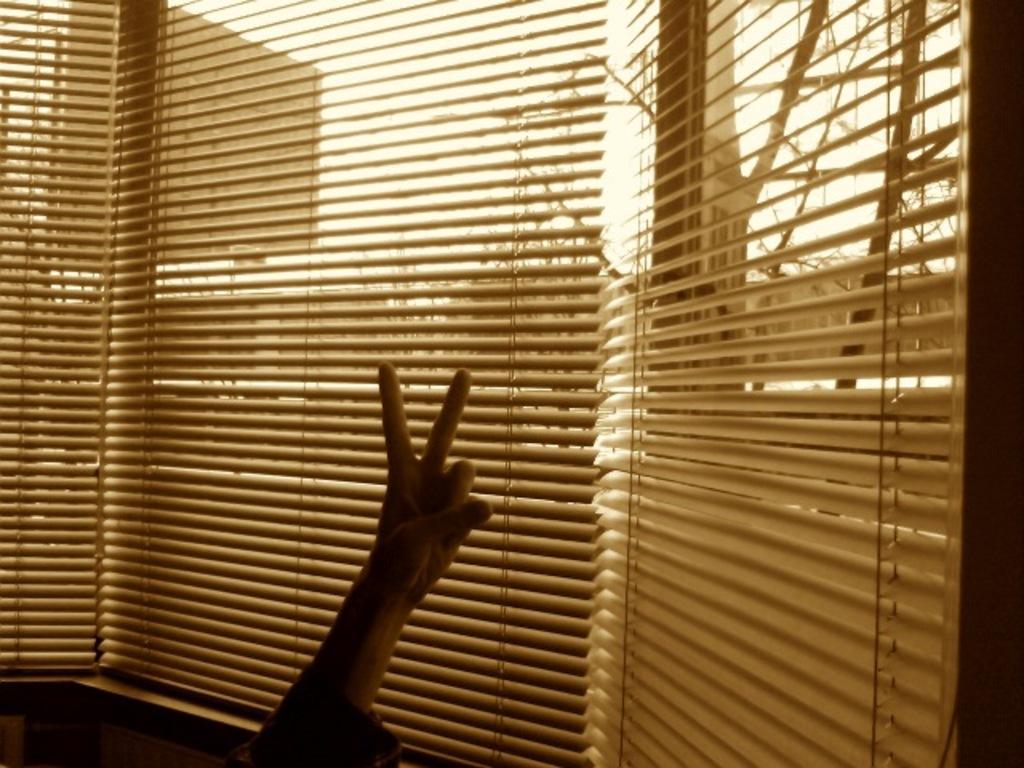Please provide a concise description of this image. In this picture there is a person. At the back there are window blinds. Behind the window blinds there are trees and there is a hoarding. At the top there is sky. 